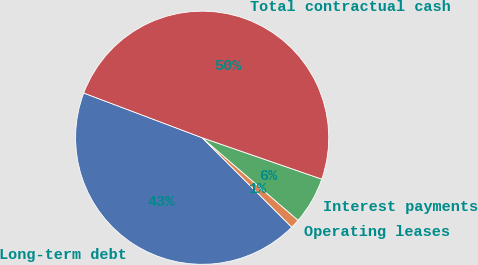<chart> <loc_0><loc_0><loc_500><loc_500><pie_chart><fcel>Long-term debt<fcel>Operating leases<fcel>Interest payments<fcel>Total contractual cash<nl><fcel>43.26%<fcel>1.17%<fcel>6.01%<fcel>49.55%<nl></chart> 